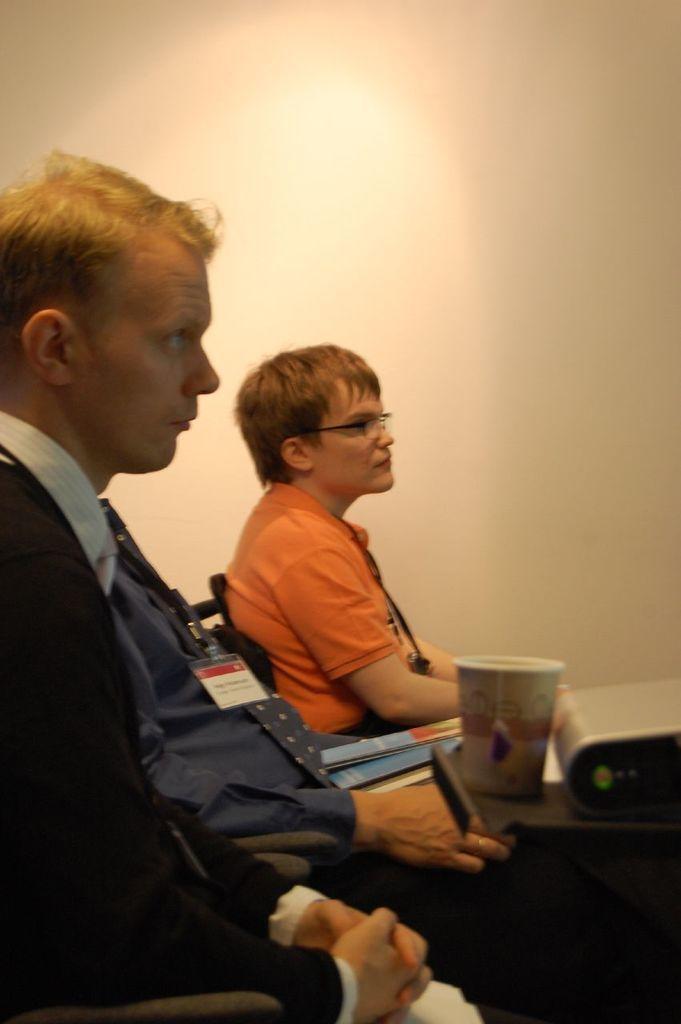Could you give a brief overview of what you see in this image? There are three people sitting in the chairs. I can see a glass and an object, which is placed on a tray. I think this is a book. In the background, that looks like a wall. 